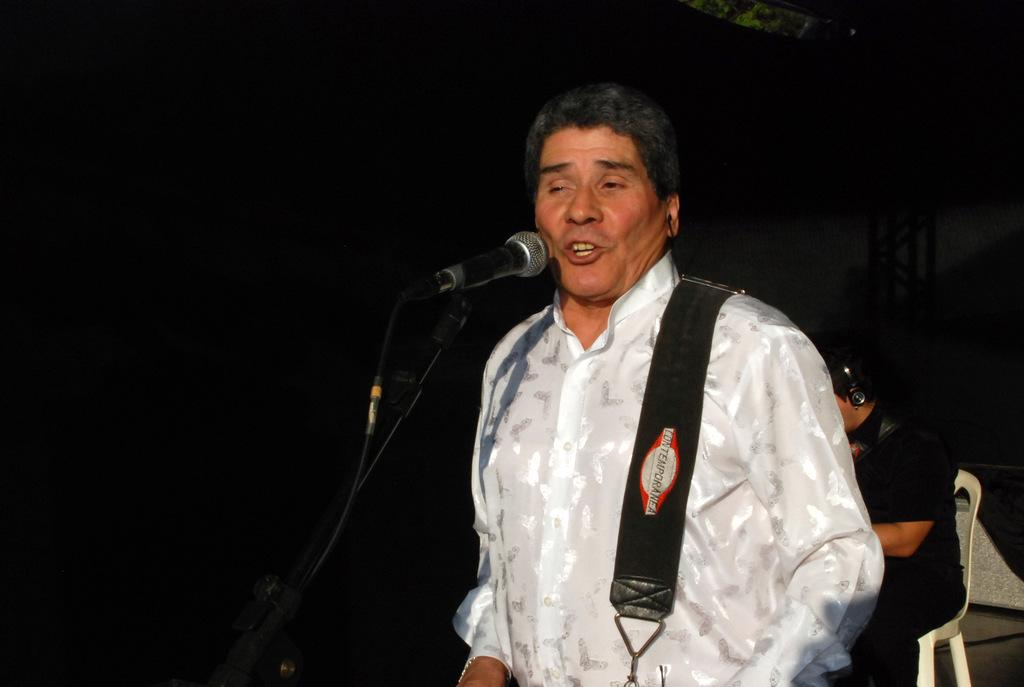Who or what is the main subject of the image? There is a person in the image. What object is visible with the person? There is a microphone (mic) in the image. Can you describe the setting or background of the image? The background appears to be dark. Are there any other people present in the image? Yes, there is another person sitting on a chair in the background. What language is the person speaking into the microphone in the image? The image does not provide any information about the language being spoken, as there is no audio or text present. Is the person in the image paying taxes while using the microphone? There is no indication in the image that the person is paying taxes or engaging in any tax-related activities. 